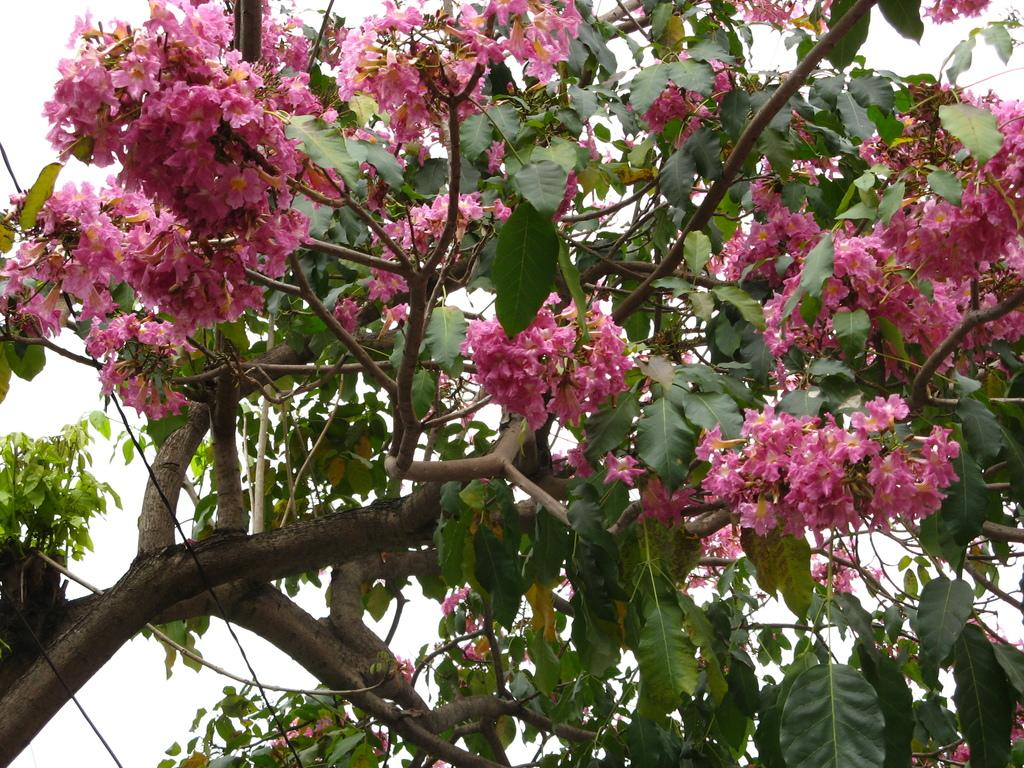What is the main subject of the picture? The main subject of the picture is a tree. What can be observed about the tree's appearance? The tree has leaves, flowers, and stems. What is visible in the background of the picture? The sky is visible in the background of the picture. What can be seen on the left side of the picture? There are cables on the left side of the picture. What type of shoes is the tree's partner wearing in the image? There is no tree partner or shoes present in the image. 